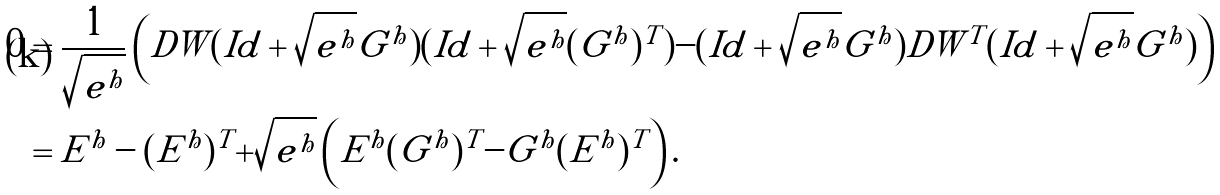Convert formula to latex. <formula><loc_0><loc_0><loc_500><loc_500>0 & = \frac { 1 } { \sqrt { e ^ { h } } } \left ( D W ( I d + \sqrt { e ^ { h } } G ^ { h } ) ( I d + \sqrt { e ^ { h } } ( G ^ { h } ) ^ { T } ) - ( I d + \sqrt { e ^ { h } } G ^ { h } ) D W ^ { T } ( I d + \sqrt { e ^ { h } } G ^ { h } ) \right ) \\ & = E ^ { h } - ( E ^ { h } ) ^ { T } + \sqrt { e ^ { h } } \left ( E ^ { h } ( G ^ { h } ) ^ { T } - G ^ { h } ( E ^ { h } ) ^ { T } \right ) .</formula> 